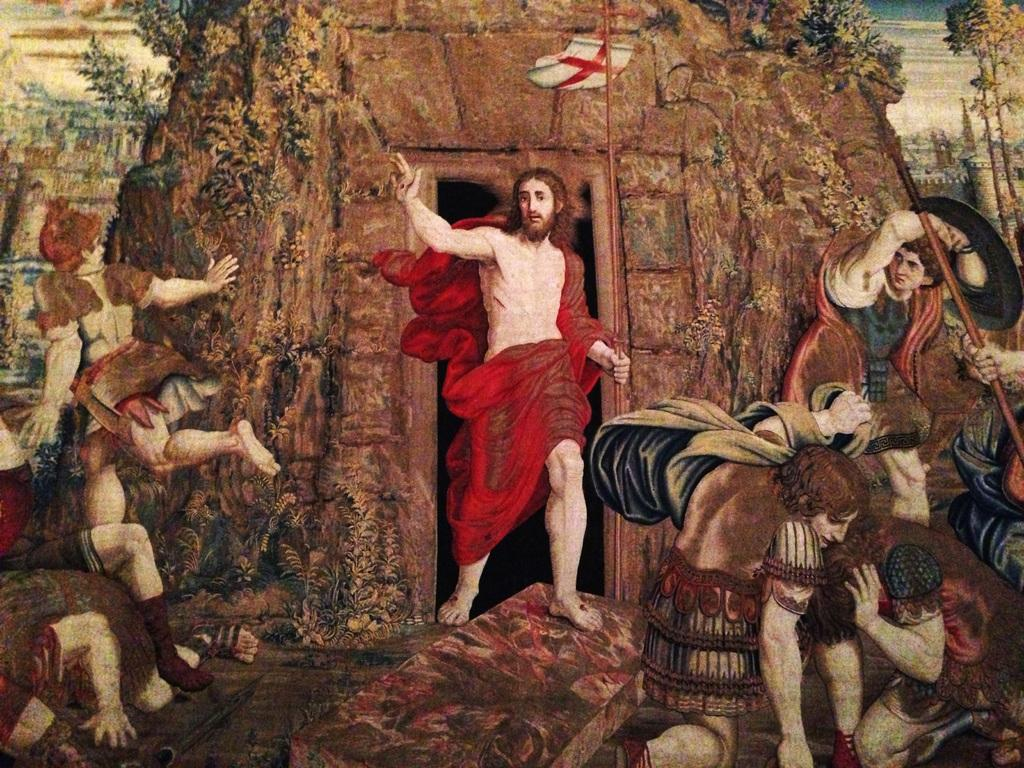What type of artwork is depicted in the image? The image is a painting. What is happening in the painting? There are people in the painting, and they are standing. What are the people holding in the painting? The people are holding sticks. What time is displayed on the clock in the painting? There is no clock present in the painting; it only features people standing and holding sticks. 